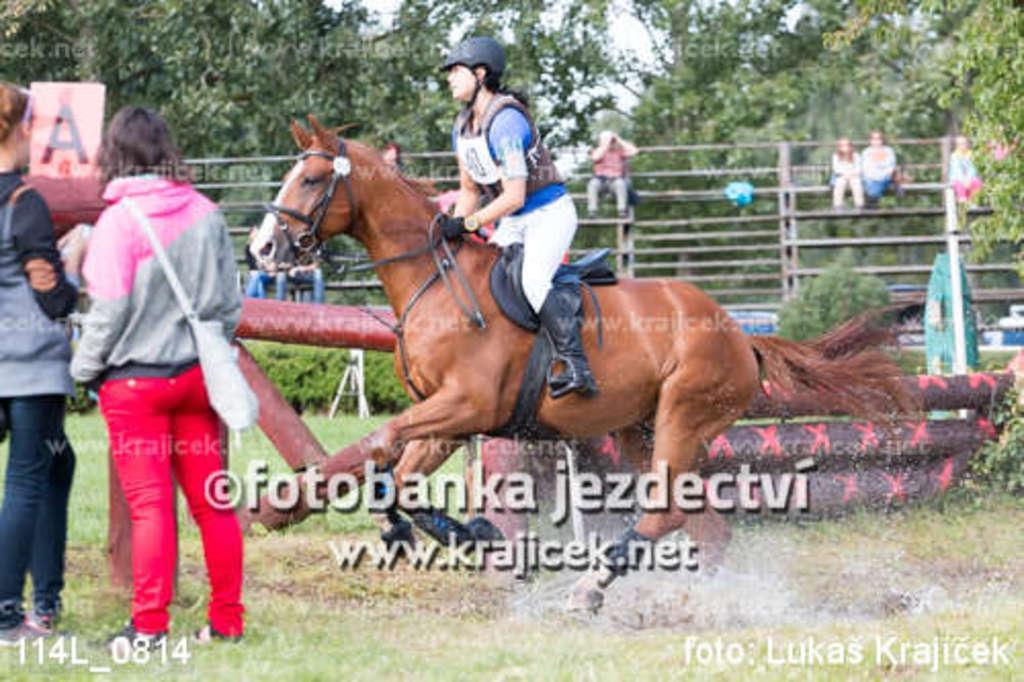Could you give a brief overview of what you see in this image? In the foreground of this image, on the left, there are two women standing on the grass and a woman is wearing a bag. In the middle, there is a woman riding a horse. Behind it, there are few objects, trees and few people sitting on the stairs and also we can see the water mark. 